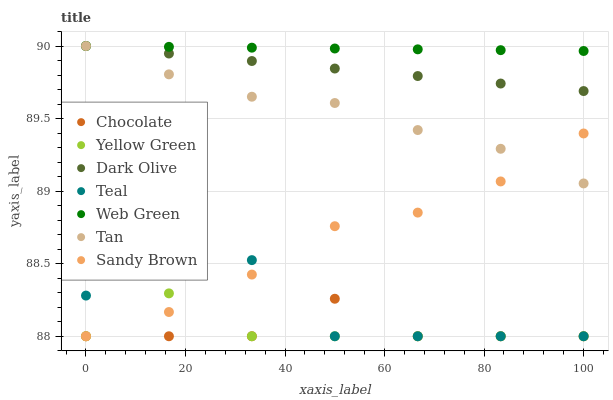Does Chocolate have the minimum area under the curve?
Answer yes or no. Yes. Does Web Green have the maximum area under the curve?
Answer yes or no. Yes. Does Dark Olive have the minimum area under the curve?
Answer yes or no. No. Does Dark Olive have the maximum area under the curve?
Answer yes or no. No. Is Dark Olive the smoothest?
Answer yes or no. Yes. Is Teal the roughest?
Answer yes or no. Yes. Is Web Green the smoothest?
Answer yes or no. No. Is Web Green the roughest?
Answer yes or no. No. Does Yellow Green have the lowest value?
Answer yes or no. Yes. Does Dark Olive have the lowest value?
Answer yes or no. No. Does Tan have the highest value?
Answer yes or no. Yes. Does Chocolate have the highest value?
Answer yes or no. No. Is Chocolate less than Tan?
Answer yes or no. Yes. Is Dark Olive greater than Yellow Green?
Answer yes or no. Yes. Does Chocolate intersect Yellow Green?
Answer yes or no. Yes. Is Chocolate less than Yellow Green?
Answer yes or no. No. Is Chocolate greater than Yellow Green?
Answer yes or no. No. Does Chocolate intersect Tan?
Answer yes or no. No. 